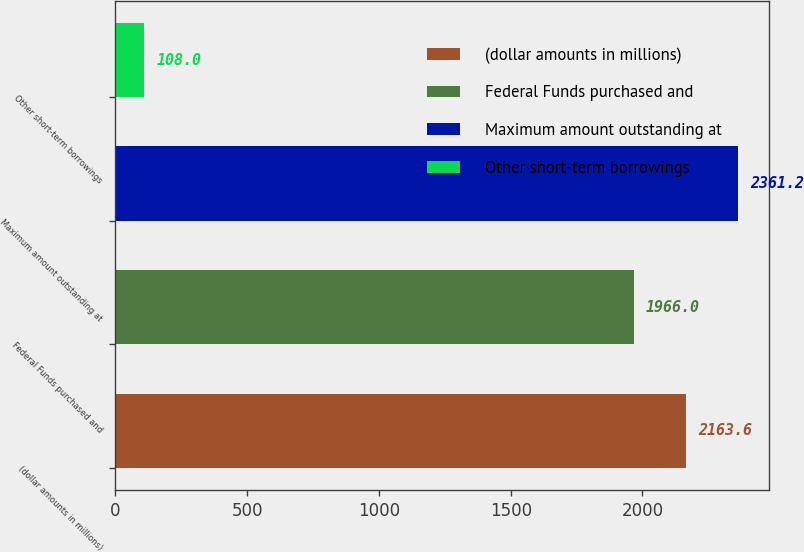<chart> <loc_0><loc_0><loc_500><loc_500><bar_chart><fcel>(dollar amounts in millions)<fcel>Federal Funds purchased and<fcel>Maximum amount outstanding at<fcel>Other short-term borrowings<nl><fcel>2163.6<fcel>1966<fcel>2361.2<fcel>108<nl></chart> 